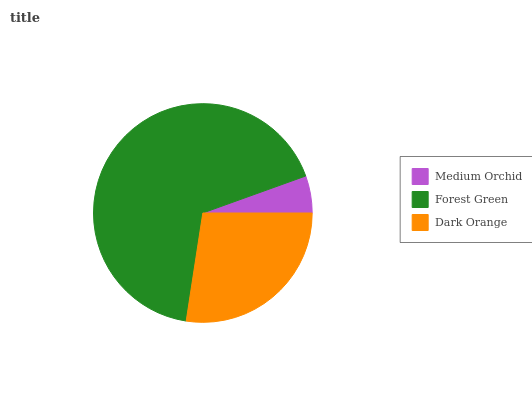Is Medium Orchid the minimum?
Answer yes or no. Yes. Is Forest Green the maximum?
Answer yes or no. Yes. Is Dark Orange the minimum?
Answer yes or no. No. Is Dark Orange the maximum?
Answer yes or no. No. Is Forest Green greater than Dark Orange?
Answer yes or no. Yes. Is Dark Orange less than Forest Green?
Answer yes or no. Yes. Is Dark Orange greater than Forest Green?
Answer yes or no. No. Is Forest Green less than Dark Orange?
Answer yes or no. No. Is Dark Orange the high median?
Answer yes or no. Yes. Is Dark Orange the low median?
Answer yes or no. Yes. Is Forest Green the high median?
Answer yes or no. No. Is Forest Green the low median?
Answer yes or no. No. 